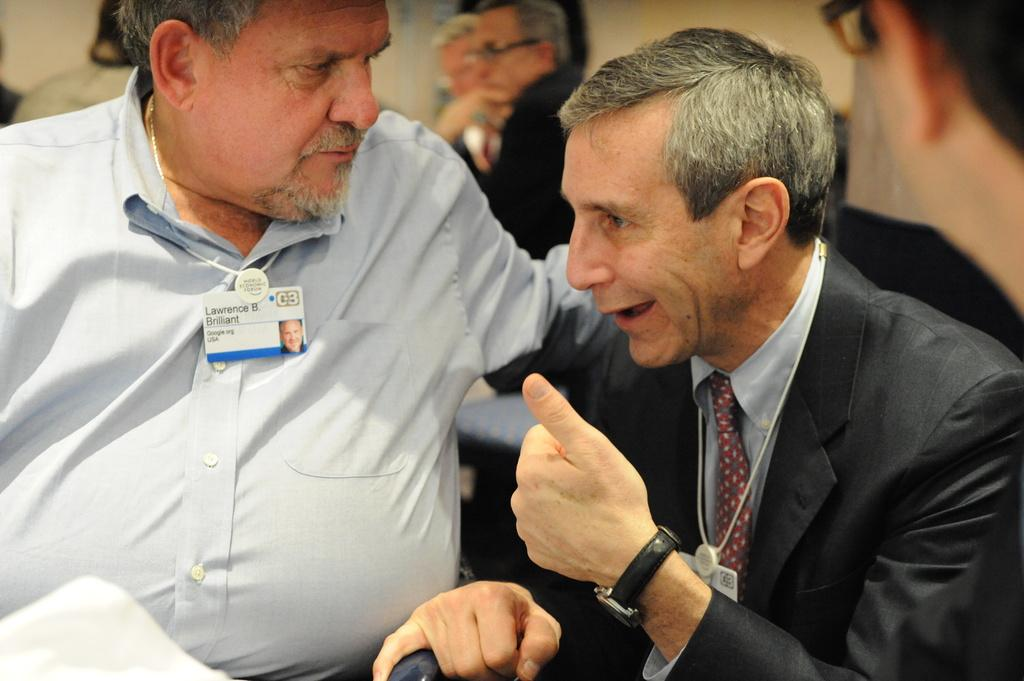How many people are sitting in the image? There are two people sitting in the image. Can you describe the people sitting in the image? Unfortunately, the facts provided do not give any details about the people sitting in the image. Are there any other people visible in the image besides the two sitting? Yes, there are people visible in the background of the image. What color is the suit worn by the person in the background? There is no mention of a suit or a person in the background in the provided facts, so we cannot answer this question. 